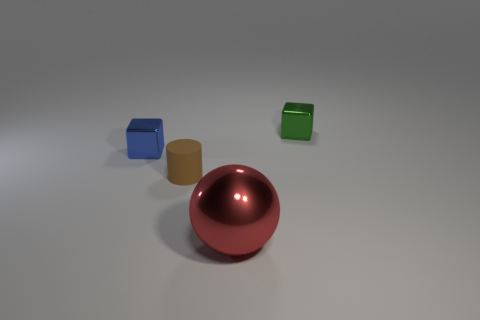What number of shiny things are tiny cylinders or small cubes? In the image, there is one tiny cylinder and two small cubes, making the total number of shiny items that are either tiny cylinders or small cubes three. 